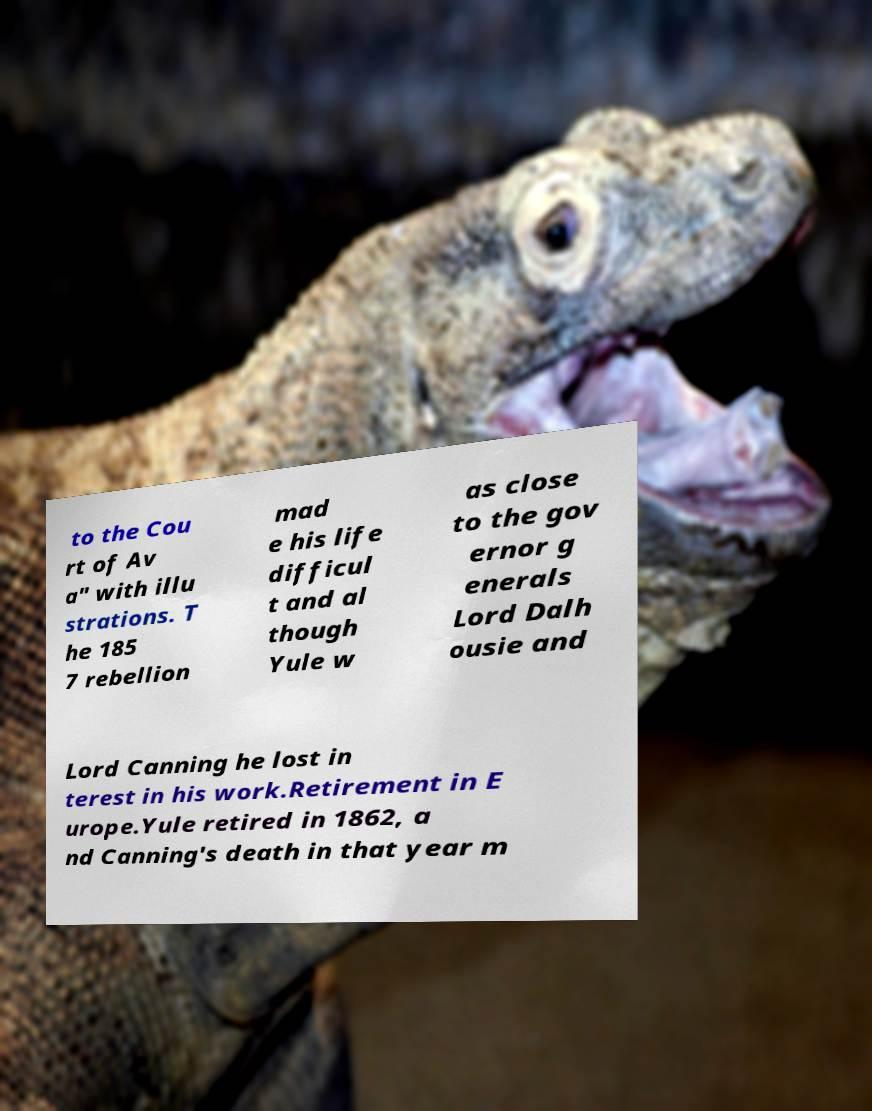Could you extract and type out the text from this image? to the Cou rt of Av a" with illu strations. T he 185 7 rebellion mad e his life difficul t and al though Yule w as close to the gov ernor g enerals Lord Dalh ousie and Lord Canning he lost in terest in his work.Retirement in E urope.Yule retired in 1862, a nd Canning's death in that year m 